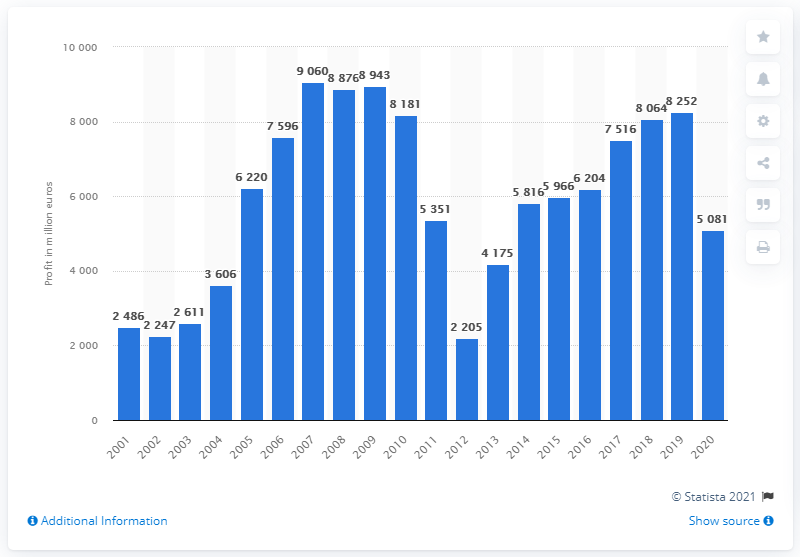Mention a couple of crucial points in this snapshot. Banco Santander reported a profit of 2,486 million in 2001. The attributable profit of the Banco Santander group in 2020 was 5081. 